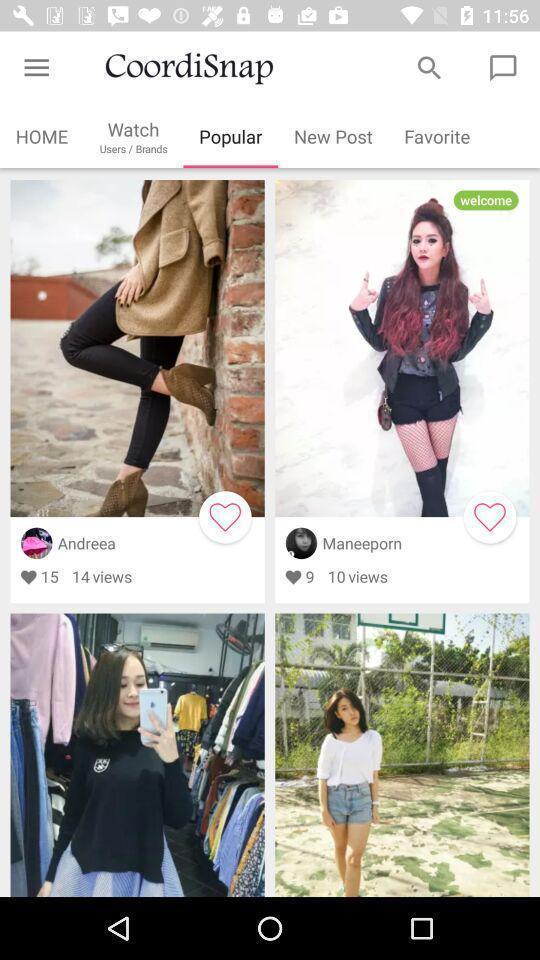What can you discern from this picture? Screen showing popular posts. 